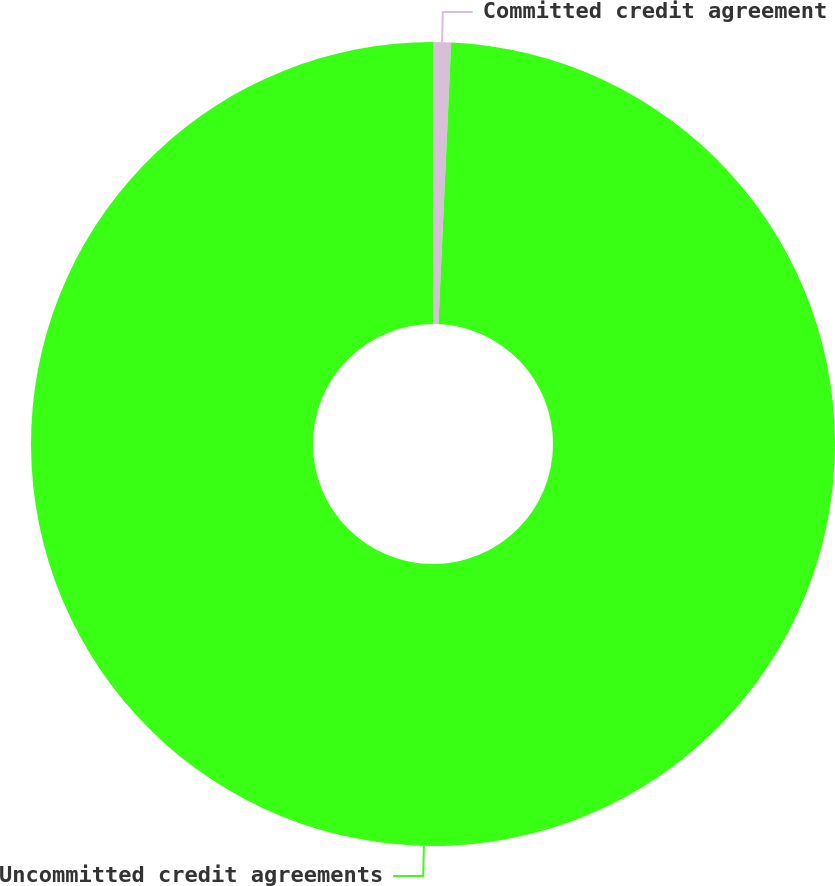Convert chart to OTSL. <chart><loc_0><loc_0><loc_500><loc_500><pie_chart><fcel>Committed credit agreement<fcel>Uncommitted credit agreements<nl><fcel>0.72%<fcel>99.28%<nl></chart> 